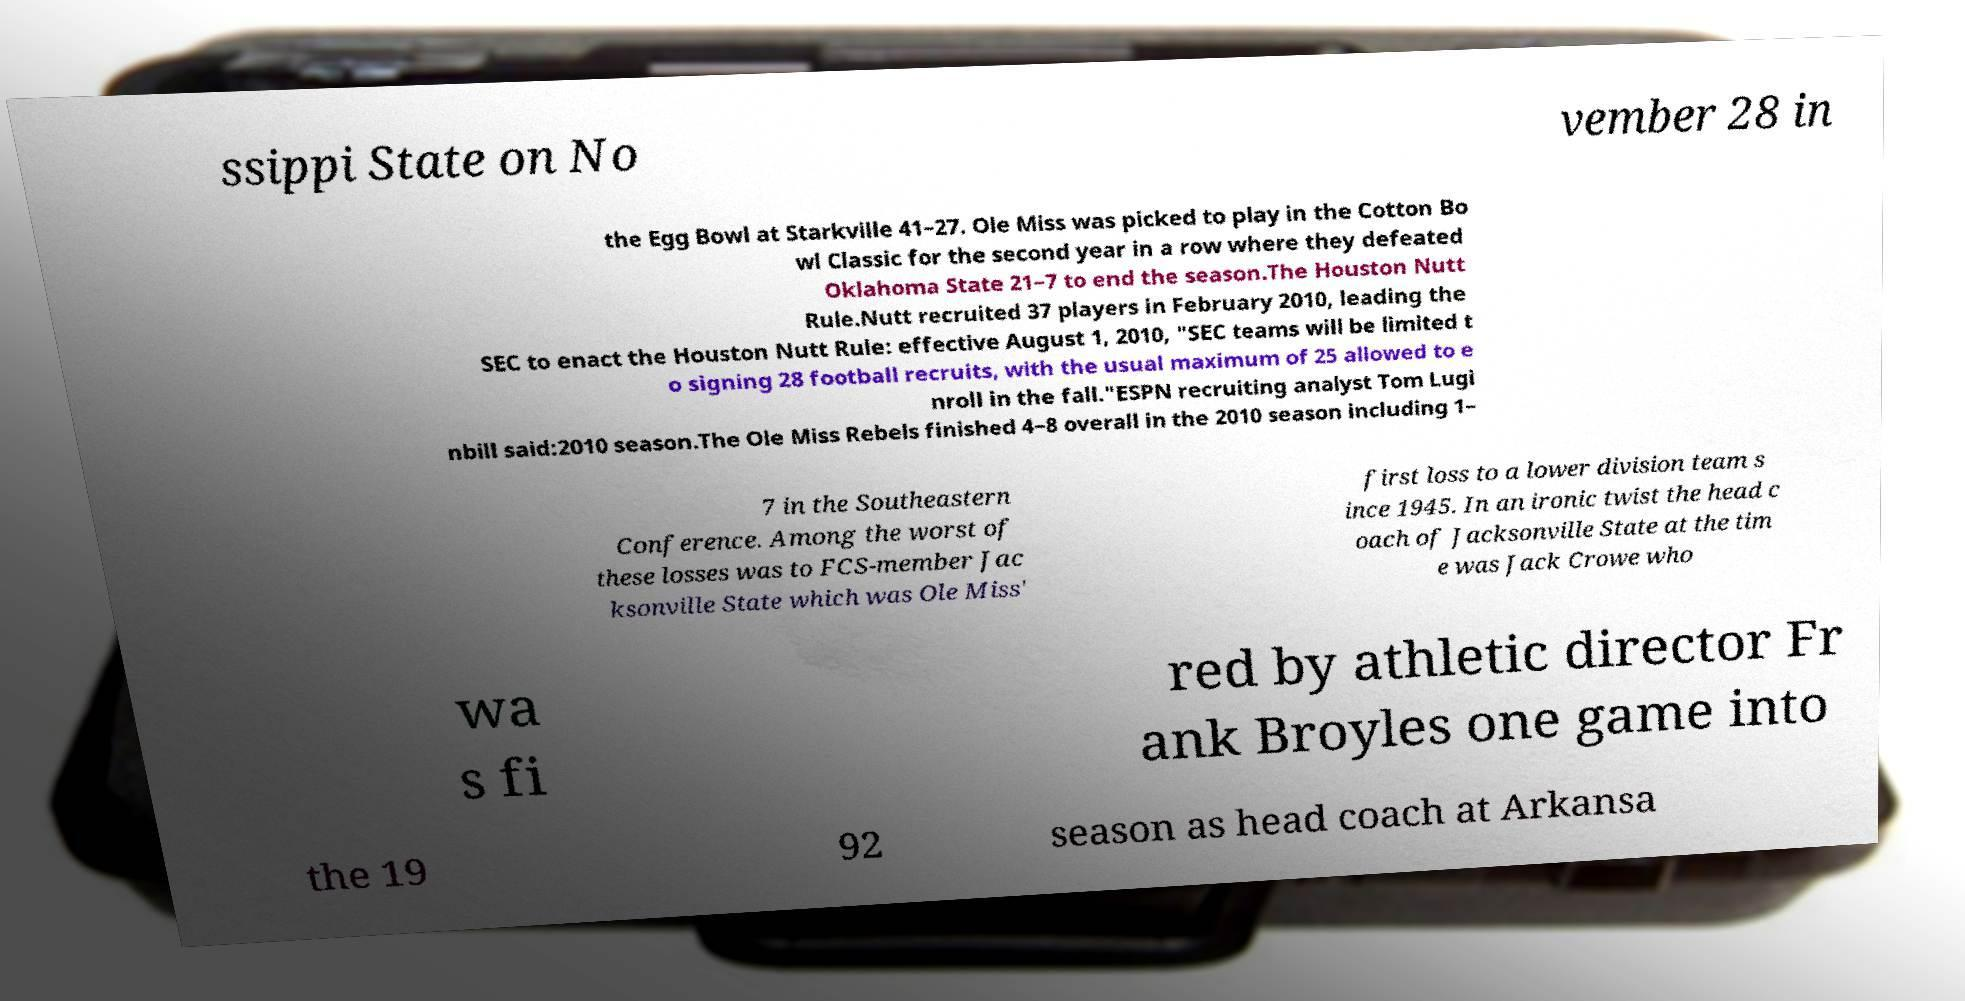Please identify and transcribe the text found in this image. ssippi State on No vember 28 in the Egg Bowl at Starkville 41–27. Ole Miss was picked to play in the Cotton Bo wl Classic for the second year in a row where they defeated Oklahoma State 21–7 to end the season.The Houston Nutt Rule.Nutt recruited 37 players in February 2010, leading the SEC to enact the Houston Nutt Rule: effective August 1, 2010, "SEC teams will be limited t o signing 28 football recruits, with the usual maximum of 25 allowed to e nroll in the fall."ESPN recruiting analyst Tom Lugi nbill said:2010 season.The Ole Miss Rebels finished 4–8 overall in the 2010 season including 1– 7 in the Southeastern Conference. Among the worst of these losses was to FCS-member Jac ksonville State which was Ole Miss' first loss to a lower division team s ince 1945. In an ironic twist the head c oach of Jacksonville State at the tim e was Jack Crowe who wa s fi red by athletic director Fr ank Broyles one game into the 19 92 season as head coach at Arkansa 